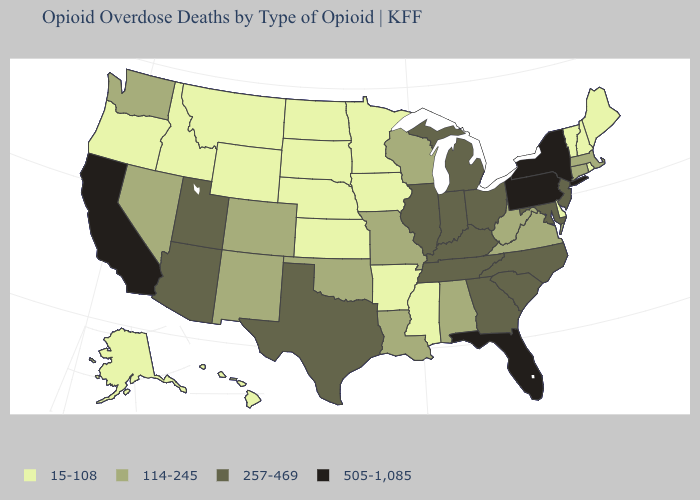What is the highest value in the USA?
Answer briefly. 505-1,085. Among the states that border Kansas , which have the highest value?
Answer briefly. Colorado, Missouri, Oklahoma. Name the states that have a value in the range 505-1,085?
Short answer required. California, Florida, New York, Pennsylvania. How many symbols are there in the legend?
Give a very brief answer. 4. Does the map have missing data?
Write a very short answer. No. What is the value of Nevada?
Quick response, please. 114-245. What is the lowest value in states that border Pennsylvania?
Quick response, please. 15-108. What is the lowest value in the USA?
Quick response, please. 15-108. What is the value of Wyoming?
Be succinct. 15-108. Does the map have missing data?
Give a very brief answer. No. What is the lowest value in states that border Kentucky?
Write a very short answer. 114-245. Name the states that have a value in the range 15-108?
Concise answer only. Alaska, Arkansas, Delaware, Hawaii, Idaho, Iowa, Kansas, Maine, Minnesota, Mississippi, Montana, Nebraska, New Hampshire, North Dakota, Oregon, Rhode Island, South Dakota, Vermont, Wyoming. What is the lowest value in the USA?
Quick response, please. 15-108. Does Pennsylvania have the highest value in the USA?
Keep it brief. Yes. Does North Carolina have the highest value in the South?
Write a very short answer. No. 